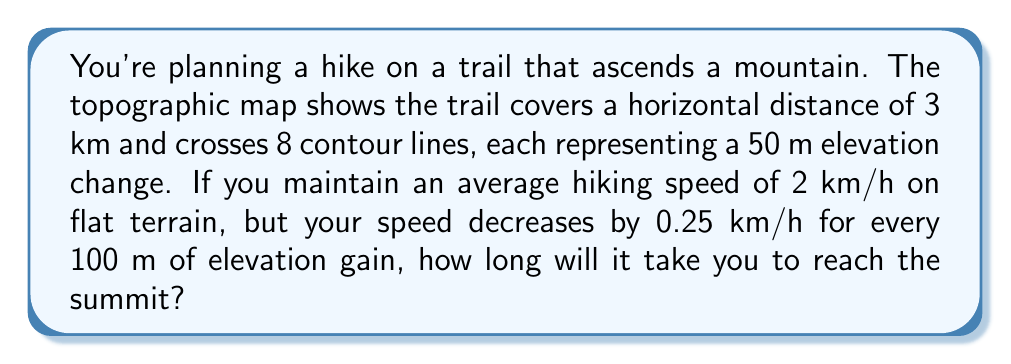Could you help me with this problem? Let's approach this problem step-by-step:

1. Calculate the total elevation gain:
   * Number of contour lines crossed = 8
   * Elevation change per contour line = 50 m
   * Total elevation gain = $8 \times 50 = 400$ m

2. Calculate the reduction in speed due to elevation gain:
   * Speed reduction per 100 m elevation = 0.25 km/h
   * Total elevation gain = 400 m
   * Total speed reduction = $400 \div 100 \times 0.25 = 1$ km/h

3. Calculate the actual hiking speed:
   * Base speed on flat terrain = 2 km/h
   * Actual speed = Base speed - Speed reduction
   * Actual speed = $2 - 1 = 1$ km/h

4. Calculate the time taken to cover the horizontal distance:
   * Horizontal distance = 3 km
   * Time = Distance ÷ Speed
   * Time = $3 \div 1 = 3$ hours

Therefore, it will take 3 hours to reach the summit.
Answer: 3 hours 